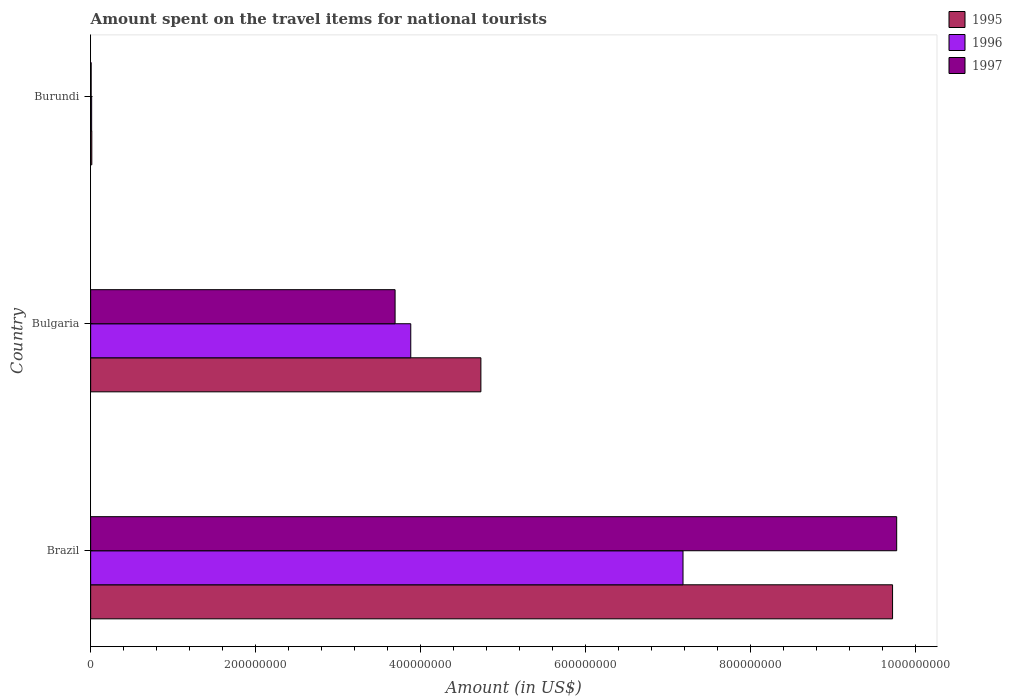How many groups of bars are there?
Make the answer very short. 3. How many bars are there on the 3rd tick from the bottom?
Offer a very short reply. 3. What is the label of the 2nd group of bars from the top?
Ensure brevity in your answer.  Bulgaria. Across all countries, what is the maximum amount spent on the travel items for national tourists in 1995?
Your answer should be compact. 9.72e+08. Across all countries, what is the minimum amount spent on the travel items for national tourists in 1997?
Ensure brevity in your answer.  6.00e+05. In which country was the amount spent on the travel items for national tourists in 1996 minimum?
Give a very brief answer. Burundi. What is the total amount spent on the travel items for national tourists in 1996 in the graph?
Your response must be concise. 1.11e+09. What is the difference between the amount spent on the travel items for national tourists in 1996 in Brazil and that in Burundi?
Your answer should be compact. 7.17e+08. What is the difference between the amount spent on the travel items for national tourists in 1997 in Burundi and the amount spent on the travel items for national tourists in 1995 in Bulgaria?
Give a very brief answer. -4.72e+08. What is the average amount spent on the travel items for national tourists in 1996 per country?
Make the answer very short. 3.69e+08. What is the difference between the amount spent on the travel items for national tourists in 1997 and amount spent on the travel items for national tourists in 1996 in Burundi?
Your answer should be compact. -6.00e+05. What is the ratio of the amount spent on the travel items for national tourists in 1995 in Bulgaria to that in Burundi?
Your answer should be compact. 337.86. Is the difference between the amount spent on the travel items for national tourists in 1997 in Brazil and Burundi greater than the difference between the amount spent on the travel items for national tourists in 1996 in Brazil and Burundi?
Provide a succinct answer. Yes. What is the difference between the highest and the second highest amount spent on the travel items for national tourists in 1997?
Offer a very short reply. 6.08e+08. What is the difference between the highest and the lowest amount spent on the travel items for national tourists in 1995?
Give a very brief answer. 9.71e+08. In how many countries, is the amount spent on the travel items for national tourists in 1996 greater than the average amount spent on the travel items for national tourists in 1996 taken over all countries?
Your response must be concise. 2. Is it the case that in every country, the sum of the amount spent on the travel items for national tourists in 1995 and amount spent on the travel items for national tourists in 1996 is greater than the amount spent on the travel items for national tourists in 1997?
Offer a very short reply. Yes. How many bars are there?
Provide a short and direct response. 9. What is the difference between two consecutive major ticks on the X-axis?
Make the answer very short. 2.00e+08. Are the values on the major ticks of X-axis written in scientific E-notation?
Provide a short and direct response. No. Where does the legend appear in the graph?
Offer a terse response. Top right. What is the title of the graph?
Your answer should be compact. Amount spent on the travel items for national tourists. What is the label or title of the Y-axis?
Ensure brevity in your answer.  Country. What is the Amount (in US$) of 1995 in Brazil?
Your answer should be very brief. 9.72e+08. What is the Amount (in US$) of 1996 in Brazil?
Provide a succinct answer. 7.18e+08. What is the Amount (in US$) of 1997 in Brazil?
Keep it short and to the point. 9.77e+08. What is the Amount (in US$) of 1995 in Bulgaria?
Ensure brevity in your answer.  4.73e+08. What is the Amount (in US$) in 1996 in Bulgaria?
Your response must be concise. 3.88e+08. What is the Amount (in US$) of 1997 in Bulgaria?
Provide a succinct answer. 3.69e+08. What is the Amount (in US$) in 1995 in Burundi?
Make the answer very short. 1.40e+06. What is the Amount (in US$) in 1996 in Burundi?
Your answer should be compact. 1.20e+06. Across all countries, what is the maximum Amount (in US$) in 1995?
Provide a succinct answer. 9.72e+08. Across all countries, what is the maximum Amount (in US$) of 1996?
Provide a succinct answer. 7.18e+08. Across all countries, what is the maximum Amount (in US$) in 1997?
Provide a short and direct response. 9.77e+08. Across all countries, what is the minimum Amount (in US$) of 1995?
Give a very brief answer. 1.40e+06. Across all countries, what is the minimum Amount (in US$) in 1996?
Make the answer very short. 1.20e+06. What is the total Amount (in US$) of 1995 in the graph?
Your response must be concise. 1.45e+09. What is the total Amount (in US$) of 1996 in the graph?
Provide a succinct answer. 1.11e+09. What is the total Amount (in US$) in 1997 in the graph?
Your response must be concise. 1.35e+09. What is the difference between the Amount (in US$) in 1995 in Brazil and that in Bulgaria?
Your answer should be compact. 4.99e+08. What is the difference between the Amount (in US$) of 1996 in Brazil and that in Bulgaria?
Give a very brief answer. 3.30e+08. What is the difference between the Amount (in US$) in 1997 in Brazil and that in Bulgaria?
Provide a succinct answer. 6.08e+08. What is the difference between the Amount (in US$) in 1995 in Brazil and that in Burundi?
Offer a very short reply. 9.71e+08. What is the difference between the Amount (in US$) of 1996 in Brazil and that in Burundi?
Provide a short and direct response. 7.17e+08. What is the difference between the Amount (in US$) in 1997 in Brazil and that in Burundi?
Offer a very short reply. 9.76e+08. What is the difference between the Amount (in US$) of 1995 in Bulgaria and that in Burundi?
Your answer should be very brief. 4.72e+08. What is the difference between the Amount (in US$) in 1996 in Bulgaria and that in Burundi?
Your answer should be compact. 3.87e+08. What is the difference between the Amount (in US$) of 1997 in Bulgaria and that in Burundi?
Offer a terse response. 3.68e+08. What is the difference between the Amount (in US$) of 1995 in Brazil and the Amount (in US$) of 1996 in Bulgaria?
Your answer should be compact. 5.84e+08. What is the difference between the Amount (in US$) of 1995 in Brazil and the Amount (in US$) of 1997 in Bulgaria?
Your response must be concise. 6.03e+08. What is the difference between the Amount (in US$) in 1996 in Brazil and the Amount (in US$) in 1997 in Bulgaria?
Offer a terse response. 3.49e+08. What is the difference between the Amount (in US$) in 1995 in Brazil and the Amount (in US$) in 1996 in Burundi?
Provide a succinct answer. 9.71e+08. What is the difference between the Amount (in US$) of 1995 in Brazil and the Amount (in US$) of 1997 in Burundi?
Your response must be concise. 9.71e+08. What is the difference between the Amount (in US$) of 1996 in Brazil and the Amount (in US$) of 1997 in Burundi?
Make the answer very short. 7.17e+08. What is the difference between the Amount (in US$) in 1995 in Bulgaria and the Amount (in US$) in 1996 in Burundi?
Offer a terse response. 4.72e+08. What is the difference between the Amount (in US$) of 1995 in Bulgaria and the Amount (in US$) of 1997 in Burundi?
Ensure brevity in your answer.  4.72e+08. What is the difference between the Amount (in US$) in 1996 in Bulgaria and the Amount (in US$) in 1997 in Burundi?
Provide a succinct answer. 3.87e+08. What is the average Amount (in US$) in 1995 per country?
Provide a succinct answer. 4.82e+08. What is the average Amount (in US$) of 1996 per country?
Give a very brief answer. 3.69e+08. What is the average Amount (in US$) of 1997 per country?
Keep it short and to the point. 4.49e+08. What is the difference between the Amount (in US$) in 1995 and Amount (in US$) in 1996 in Brazil?
Make the answer very short. 2.54e+08. What is the difference between the Amount (in US$) in 1995 and Amount (in US$) in 1997 in Brazil?
Give a very brief answer. -5.00e+06. What is the difference between the Amount (in US$) in 1996 and Amount (in US$) in 1997 in Brazil?
Offer a very short reply. -2.59e+08. What is the difference between the Amount (in US$) in 1995 and Amount (in US$) in 1996 in Bulgaria?
Give a very brief answer. 8.50e+07. What is the difference between the Amount (in US$) of 1995 and Amount (in US$) of 1997 in Bulgaria?
Give a very brief answer. 1.04e+08. What is the difference between the Amount (in US$) in 1996 and Amount (in US$) in 1997 in Bulgaria?
Ensure brevity in your answer.  1.90e+07. What is the difference between the Amount (in US$) of 1996 and Amount (in US$) of 1997 in Burundi?
Give a very brief answer. 6.00e+05. What is the ratio of the Amount (in US$) of 1995 in Brazil to that in Bulgaria?
Offer a very short reply. 2.06. What is the ratio of the Amount (in US$) of 1996 in Brazil to that in Bulgaria?
Provide a succinct answer. 1.85. What is the ratio of the Amount (in US$) in 1997 in Brazil to that in Bulgaria?
Provide a short and direct response. 2.65. What is the ratio of the Amount (in US$) in 1995 in Brazil to that in Burundi?
Provide a succinct answer. 694.29. What is the ratio of the Amount (in US$) of 1996 in Brazil to that in Burundi?
Your answer should be very brief. 598.33. What is the ratio of the Amount (in US$) of 1997 in Brazil to that in Burundi?
Offer a very short reply. 1628.33. What is the ratio of the Amount (in US$) in 1995 in Bulgaria to that in Burundi?
Make the answer very short. 337.86. What is the ratio of the Amount (in US$) of 1996 in Bulgaria to that in Burundi?
Your response must be concise. 323.33. What is the ratio of the Amount (in US$) of 1997 in Bulgaria to that in Burundi?
Your answer should be very brief. 615. What is the difference between the highest and the second highest Amount (in US$) in 1995?
Offer a very short reply. 4.99e+08. What is the difference between the highest and the second highest Amount (in US$) of 1996?
Ensure brevity in your answer.  3.30e+08. What is the difference between the highest and the second highest Amount (in US$) in 1997?
Give a very brief answer. 6.08e+08. What is the difference between the highest and the lowest Amount (in US$) of 1995?
Make the answer very short. 9.71e+08. What is the difference between the highest and the lowest Amount (in US$) of 1996?
Offer a very short reply. 7.17e+08. What is the difference between the highest and the lowest Amount (in US$) of 1997?
Keep it short and to the point. 9.76e+08. 